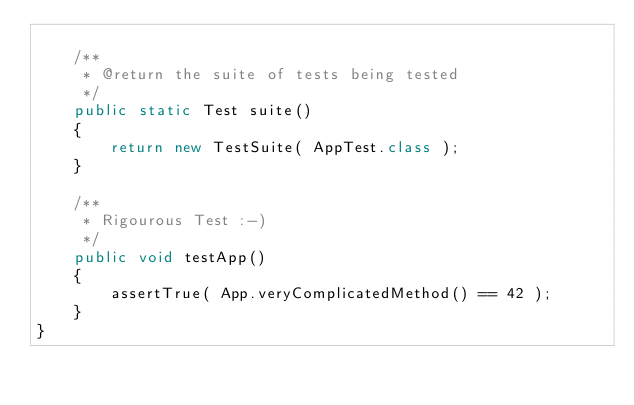Convert code to text. <code><loc_0><loc_0><loc_500><loc_500><_Java_>
    /**
     * @return the suite of tests being tested
     */
    public static Test suite()
    {
        return new TestSuite( AppTest.class );
    }

    /**
     * Rigourous Test :-)
     */
    public void testApp()
    {
        assertTrue( App.veryComplicatedMethod() == 42 );
    }
}
</code> 